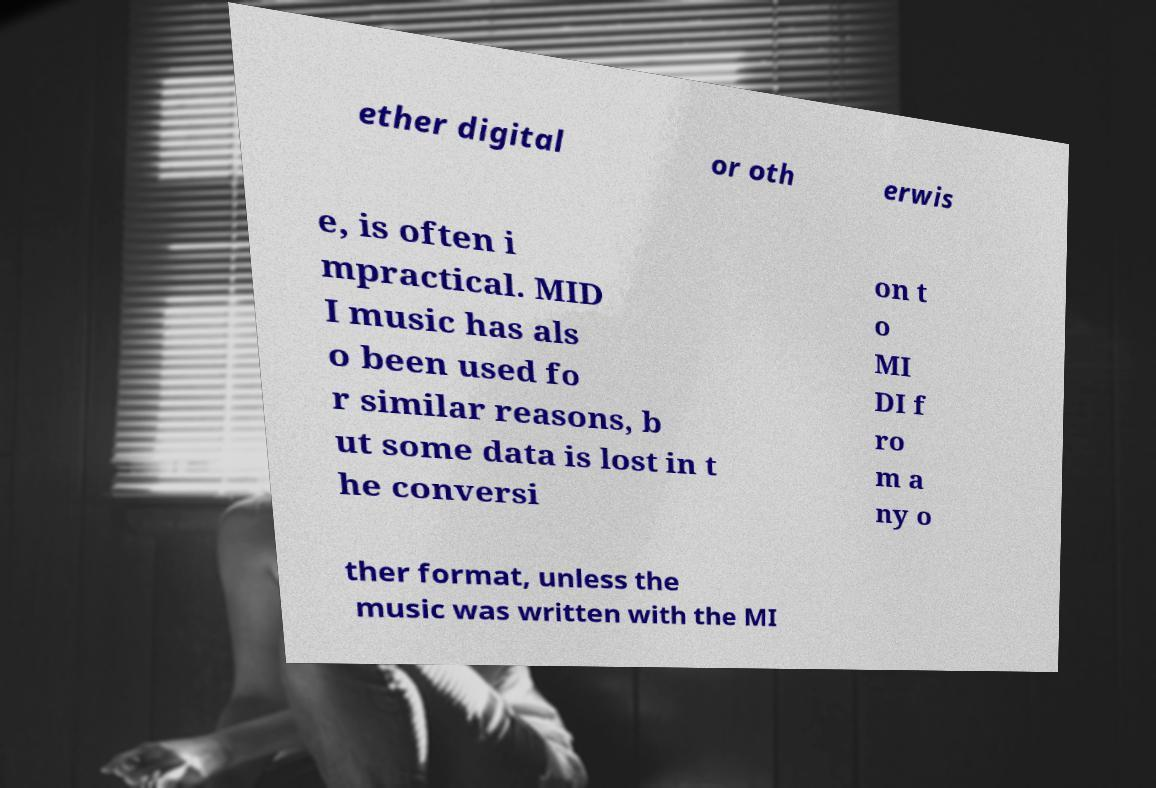For documentation purposes, I need the text within this image transcribed. Could you provide that? ether digital or oth erwis e, is often i mpractical. MID I music has als o been used fo r similar reasons, b ut some data is lost in t he conversi on t o MI DI f ro m a ny o ther format, unless the music was written with the MI 